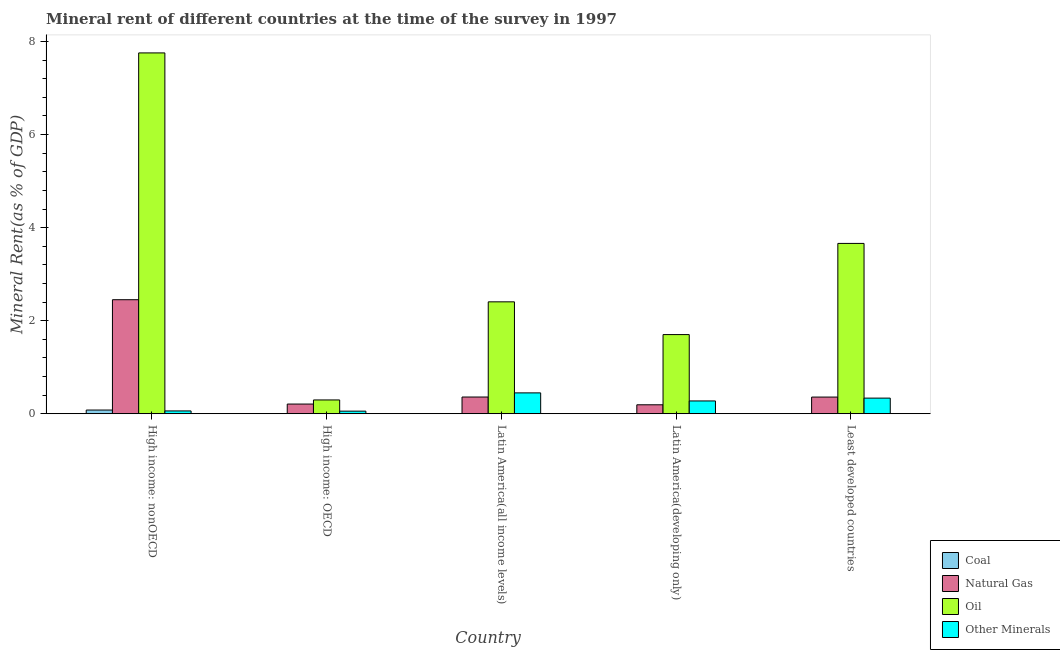How many bars are there on the 5th tick from the left?
Provide a short and direct response. 4. What is the label of the 1st group of bars from the left?
Provide a succinct answer. High income: nonOECD. In how many cases, is the number of bars for a given country not equal to the number of legend labels?
Your answer should be compact. 0. What is the oil rent in Latin America(all income levels)?
Provide a short and direct response. 2.4. Across all countries, what is the maximum oil rent?
Provide a short and direct response. 7.75. Across all countries, what is the minimum  rent of other minerals?
Give a very brief answer. 0.06. In which country was the coal rent maximum?
Give a very brief answer. High income: nonOECD. In which country was the natural gas rent minimum?
Offer a very short reply. Latin America(developing only). What is the total coal rent in the graph?
Give a very brief answer. 0.09. What is the difference between the oil rent in Latin America(all income levels) and that in Latin America(developing only)?
Give a very brief answer. 0.7. What is the difference between the natural gas rent in Latin America(all income levels) and the  rent of other minerals in Latin America(developing only)?
Offer a terse response. 0.08. What is the average  rent of other minerals per country?
Offer a very short reply. 0.23. What is the difference between the natural gas rent and  rent of other minerals in High income: nonOECD?
Your response must be concise. 2.39. What is the ratio of the  rent of other minerals in High income: nonOECD to that in Least developed countries?
Ensure brevity in your answer.  0.18. What is the difference between the highest and the second highest  rent of other minerals?
Make the answer very short. 0.11. What is the difference between the highest and the lowest oil rent?
Ensure brevity in your answer.  7.46. In how many countries, is the oil rent greater than the average oil rent taken over all countries?
Keep it short and to the point. 2. What does the 2nd bar from the left in Latin America(all income levels) represents?
Give a very brief answer. Natural Gas. What does the 1st bar from the right in Latin America(all income levels) represents?
Give a very brief answer. Other Minerals. Is it the case that in every country, the sum of the coal rent and natural gas rent is greater than the oil rent?
Keep it short and to the point. No. Are all the bars in the graph horizontal?
Offer a terse response. No. How many countries are there in the graph?
Your answer should be compact. 5. Does the graph contain grids?
Offer a terse response. No. How many legend labels are there?
Offer a very short reply. 4. How are the legend labels stacked?
Offer a very short reply. Vertical. What is the title of the graph?
Provide a succinct answer. Mineral rent of different countries at the time of the survey in 1997. What is the label or title of the X-axis?
Provide a succinct answer. Country. What is the label or title of the Y-axis?
Offer a very short reply. Mineral Rent(as % of GDP). What is the Mineral Rent(as % of GDP) of Coal in High income: nonOECD?
Ensure brevity in your answer.  0.08. What is the Mineral Rent(as % of GDP) of Natural Gas in High income: nonOECD?
Provide a succinct answer. 2.45. What is the Mineral Rent(as % of GDP) in Oil in High income: nonOECD?
Your response must be concise. 7.75. What is the Mineral Rent(as % of GDP) of Other Minerals in High income: nonOECD?
Give a very brief answer. 0.06. What is the Mineral Rent(as % of GDP) of Coal in High income: OECD?
Your answer should be very brief. 0. What is the Mineral Rent(as % of GDP) in Natural Gas in High income: OECD?
Offer a terse response. 0.21. What is the Mineral Rent(as % of GDP) in Oil in High income: OECD?
Your response must be concise. 0.3. What is the Mineral Rent(as % of GDP) in Other Minerals in High income: OECD?
Ensure brevity in your answer.  0.06. What is the Mineral Rent(as % of GDP) in Coal in Latin America(all income levels)?
Make the answer very short. 0. What is the Mineral Rent(as % of GDP) in Natural Gas in Latin America(all income levels)?
Make the answer very short. 0.36. What is the Mineral Rent(as % of GDP) in Oil in Latin America(all income levels)?
Provide a short and direct response. 2.4. What is the Mineral Rent(as % of GDP) in Other Minerals in Latin America(all income levels)?
Offer a very short reply. 0.45. What is the Mineral Rent(as % of GDP) in Coal in Latin America(developing only)?
Make the answer very short. 0. What is the Mineral Rent(as % of GDP) of Natural Gas in Latin America(developing only)?
Make the answer very short. 0.19. What is the Mineral Rent(as % of GDP) of Oil in Latin America(developing only)?
Make the answer very short. 1.7. What is the Mineral Rent(as % of GDP) of Other Minerals in Latin America(developing only)?
Ensure brevity in your answer.  0.27. What is the Mineral Rent(as % of GDP) in Coal in Least developed countries?
Keep it short and to the point. 0. What is the Mineral Rent(as % of GDP) of Natural Gas in Least developed countries?
Offer a very short reply. 0.36. What is the Mineral Rent(as % of GDP) in Oil in Least developed countries?
Your answer should be compact. 3.66. What is the Mineral Rent(as % of GDP) of Other Minerals in Least developed countries?
Keep it short and to the point. 0.34. Across all countries, what is the maximum Mineral Rent(as % of GDP) of Coal?
Offer a very short reply. 0.08. Across all countries, what is the maximum Mineral Rent(as % of GDP) in Natural Gas?
Provide a succinct answer. 2.45. Across all countries, what is the maximum Mineral Rent(as % of GDP) in Oil?
Provide a succinct answer. 7.75. Across all countries, what is the maximum Mineral Rent(as % of GDP) in Other Minerals?
Offer a terse response. 0.45. Across all countries, what is the minimum Mineral Rent(as % of GDP) in Coal?
Make the answer very short. 0. Across all countries, what is the minimum Mineral Rent(as % of GDP) in Natural Gas?
Offer a terse response. 0.19. Across all countries, what is the minimum Mineral Rent(as % of GDP) of Oil?
Offer a very short reply. 0.3. Across all countries, what is the minimum Mineral Rent(as % of GDP) of Other Minerals?
Your answer should be very brief. 0.06. What is the total Mineral Rent(as % of GDP) in Coal in the graph?
Offer a terse response. 0.09. What is the total Mineral Rent(as % of GDP) of Natural Gas in the graph?
Your answer should be compact. 3.57. What is the total Mineral Rent(as % of GDP) in Oil in the graph?
Your answer should be compact. 15.82. What is the total Mineral Rent(as % of GDP) of Other Minerals in the graph?
Provide a short and direct response. 1.17. What is the difference between the Mineral Rent(as % of GDP) of Coal in High income: nonOECD and that in High income: OECD?
Provide a short and direct response. 0.08. What is the difference between the Mineral Rent(as % of GDP) in Natural Gas in High income: nonOECD and that in High income: OECD?
Make the answer very short. 2.24. What is the difference between the Mineral Rent(as % of GDP) of Oil in High income: nonOECD and that in High income: OECD?
Keep it short and to the point. 7.46. What is the difference between the Mineral Rent(as % of GDP) in Other Minerals in High income: nonOECD and that in High income: OECD?
Ensure brevity in your answer.  0. What is the difference between the Mineral Rent(as % of GDP) of Coal in High income: nonOECD and that in Latin America(all income levels)?
Keep it short and to the point. 0.08. What is the difference between the Mineral Rent(as % of GDP) of Natural Gas in High income: nonOECD and that in Latin America(all income levels)?
Your answer should be compact. 2.09. What is the difference between the Mineral Rent(as % of GDP) of Oil in High income: nonOECD and that in Latin America(all income levels)?
Ensure brevity in your answer.  5.35. What is the difference between the Mineral Rent(as % of GDP) in Other Minerals in High income: nonOECD and that in Latin America(all income levels)?
Your answer should be compact. -0.39. What is the difference between the Mineral Rent(as % of GDP) of Coal in High income: nonOECD and that in Latin America(developing only)?
Give a very brief answer. 0.08. What is the difference between the Mineral Rent(as % of GDP) of Natural Gas in High income: nonOECD and that in Latin America(developing only)?
Offer a very short reply. 2.26. What is the difference between the Mineral Rent(as % of GDP) of Oil in High income: nonOECD and that in Latin America(developing only)?
Offer a very short reply. 6.05. What is the difference between the Mineral Rent(as % of GDP) in Other Minerals in High income: nonOECD and that in Latin America(developing only)?
Give a very brief answer. -0.21. What is the difference between the Mineral Rent(as % of GDP) of Coal in High income: nonOECD and that in Least developed countries?
Your response must be concise. 0.08. What is the difference between the Mineral Rent(as % of GDP) of Natural Gas in High income: nonOECD and that in Least developed countries?
Your answer should be compact. 2.09. What is the difference between the Mineral Rent(as % of GDP) in Oil in High income: nonOECD and that in Least developed countries?
Offer a terse response. 4.09. What is the difference between the Mineral Rent(as % of GDP) in Other Minerals in High income: nonOECD and that in Least developed countries?
Keep it short and to the point. -0.28. What is the difference between the Mineral Rent(as % of GDP) of Coal in High income: OECD and that in Latin America(all income levels)?
Make the answer very short. 0. What is the difference between the Mineral Rent(as % of GDP) of Natural Gas in High income: OECD and that in Latin America(all income levels)?
Make the answer very short. -0.15. What is the difference between the Mineral Rent(as % of GDP) of Oil in High income: OECD and that in Latin America(all income levels)?
Provide a succinct answer. -2.11. What is the difference between the Mineral Rent(as % of GDP) of Other Minerals in High income: OECD and that in Latin America(all income levels)?
Ensure brevity in your answer.  -0.39. What is the difference between the Mineral Rent(as % of GDP) in Coal in High income: OECD and that in Latin America(developing only)?
Your answer should be compact. -0. What is the difference between the Mineral Rent(as % of GDP) of Natural Gas in High income: OECD and that in Latin America(developing only)?
Offer a terse response. 0.02. What is the difference between the Mineral Rent(as % of GDP) in Oil in High income: OECD and that in Latin America(developing only)?
Give a very brief answer. -1.4. What is the difference between the Mineral Rent(as % of GDP) of Other Minerals in High income: OECD and that in Latin America(developing only)?
Give a very brief answer. -0.22. What is the difference between the Mineral Rent(as % of GDP) in Coal in High income: OECD and that in Least developed countries?
Offer a very short reply. 0. What is the difference between the Mineral Rent(as % of GDP) of Natural Gas in High income: OECD and that in Least developed countries?
Provide a short and direct response. -0.15. What is the difference between the Mineral Rent(as % of GDP) of Oil in High income: OECD and that in Least developed countries?
Your response must be concise. -3.36. What is the difference between the Mineral Rent(as % of GDP) of Other Minerals in High income: OECD and that in Least developed countries?
Give a very brief answer. -0.28. What is the difference between the Mineral Rent(as % of GDP) of Coal in Latin America(all income levels) and that in Latin America(developing only)?
Provide a succinct answer. -0. What is the difference between the Mineral Rent(as % of GDP) in Oil in Latin America(all income levels) and that in Latin America(developing only)?
Provide a succinct answer. 0.7. What is the difference between the Mineral Rent(as % of GDP) of Other Minerals in Latin America(all income levels) and that in Latin America(developing only)?
Your answer should be very brief. 0.17. What is the difference between the Mineral Rent(as % of GDP) in Coal in Latin America(all income levels) and that in Least developed countries?
Your answer should be compact. 0. What is the difference between the Mineral Rent(as % of GDP) of Natural Gas in Latin America(all income levels) and that in Least developed countries?
Make the answer very short. 0. What is the difference between the Mineral Rent(as % of GDP) in Oil in Latin America(all income levels) and that in Least developed countries?
Offer a terse response. -1.26. What is the difference between the Mineral Rent(as % of GDP) in Other Minerals in Latin America(all income levels) and that in Least developed countries?
Your answer should be very brief. 0.11. What is the difference between the Mineral Rent(as % of GDP) in Coal in Latin America(developing only) and that in Least developed countries?
Give a very brief answer. 0. What is the difference between the Mineral Rent(as % of GDP) of Natural Gas in Latin America(developing only) and that in Least developed countries?
Keep it short and to the point. -0.17. What is the difference between the Mineral Rent(as % of GDP) in Oil in Latin America(developing only) and that in Least developed countries?
Your answer should be very brief. -1.96. What is the difference between the Mineral Rent(as % of GDP) in Other Minerals in Latin America(developing only) and that in Least developed countries?
Keep it short and to the point. -0.06. What is the difference between the Mineral Rent(as % of GDP) of Coal in High income: nonOECD and the Mineral Rent(as % of GDP) of Natural Gas in High income: OECD?
Your answer should be very brief. -0.13. What is the difference between the Mineral Rent(as % of GDP) in Coal in High income: nonOECD and the Mineral Rent(as % of GDP) in Oil in High income: OECD?
Keep it short and to the point. -0.22. What is the difference between the Mineral Rent(as % of GDP) in Coal in High income: nonOECD and the Mineral Rent(as % of GDP) in Other Minerals in High income: OECD?
Provide a succinct answer. 0.02. What is the difference between the Mineral Rent(as % of GDP) in Natural Gas in High income: nonOECD and the Mineral Rent(as % of GDP) in Oil in High income: OECD?
Your answer should be compact. 2.15. What is the difference between the Mineral Rent(as % of GDP) of Natural Gas in High income: nonOECD and the Mineral Rent(as % of GDP) of Other Minerals in High income: OECD?
Ensure brevity in your answer.  2.4. What is the difference between the Mineral Rent(as % of GDP) in Oil in High income: nonOECD and the Mineral Rent(as % of GDP) in Other Minerals in High income: OECD?
Provide a succinct answer. 7.7. What is the difference between the Mineral Rent(as % of GDP) of Coal in High income: nonOECD and the Mineral Rent(as % of GDP) of Natural Gas in Latin America(all income levels)?
Keep it short and to the point. -0.28. What is the difference between the Mineral Rent(as % of GDP) of Coal in High income: nonOECD and the Mineral Rent(as % of GDP) of Oil in Latin America(all income levels)?
Ensure brevity in your answer.  -2.33. What is the difference between the Mineral Rent(as % of GDP) in Coal in High income: nonOECD and the Mineral Rent(as % of GDP) in Other Minerals in Latin America(all income levels)?
Make the answer very short. -0.37. What is the difference between the Mineral Rent(as % of GDP) in Natural Gas in High income: nonOECD and the Mineral Rent(as % of GDP) in Oil in Latin America(all income levels)?
Offer a very short reply. 0.05. What is the difference between the Mineral Rent(as % of GDP) in Natural Gas in High income: nonOECD and the Mineral Rent(as % of GDP) in Other Minerals in Latin America(all income levels)?
Provide a short and direct response. 2. What is the difference between the Mineral Rent(as % of GDP) of Oil in High income: nonOECD and the Mineral Rent(as % of GDP) of Other Minerals in Latin America(all income levels)?
Keep it short and to the point. 7.31. What is the difference between the Mineral Rent(as % of GDP) of Coal in High income: nonOECD and the Mineral Rent(as % of GDP) of Natural Gas in Latin America(developing only)?
Give a very brief answer. -0.11. What is the difference between the Mineral Rent(as % of GDP) in Coal in High income: nonOECD and the Mineral Rent(as % of GDP) in Oil in Latin America(developing only)?
Your answer should be very brief. -1.62. What is the difference between the Mineral Rent(as % of GDP) of Coal in High income: nonOECD and the Mineral Rent(as % of GDP) of Other Minerals in Latin America(developing only)?
Make the answer very short. -0.2. What is the difference between the Mineral Rent(as % of GDP) of Natural Gas in High income: nonOECD and the Mineral Rent(as % of GDP) of Oil in Latin America(developing only)?
Provide a succinct answer. 0.75. What is the difference between the Mineral Rent(as % of GDP) of Natural Gas in High income: nonOECD and the Mineral Rent(as % of GDP) of Other Minerals in Latin America(developing only)?
Give a very brief answer. 2.18. What is the difference between the Mineral Rent(as % of GDP) of Oil in High income: nonOECD and the Mineral Rent(as % of GDP) of Other Minerals in Latin America(developing only)?
Ensure brevity in your answer.  7.48. What is the difference between the Mineral Rent(as % of GDP) of Coal in High income: nonOECD and the Mineral Rent(as % of GDP) of Natural Gas in Least developed countries?
Provide a succinct answer. -0.28. What is the difference between the Mineral Rent(as % of GDP) of Coal in High income: nonOECD and the Mineral Rent(as % of GDP) of Oil in Least developed countries?
Give a very brief answer. -3.58. What is the difference between the Mineral Rent(as % of GDP) of Coal in High income: nonOECD and the Mineral Rent(as % of GDP) of Other Minerals in Least developed countries?
Provide a short and direct response. -0.26. What is the difference between the Mineral Rent(as % of GDP) in Natural Gas in High income: nonOECD and the Mineral Rent(as % of GDP) in Oil in Least developed countries?
Offer a terse response. -1.21. What is the difference between the Mineral Rent(as % of GDP) of Natural Gas in High income: nonOECD and the Mineral Rent(as % of GDP) of Other Minerals in Least developed countries?
Your answer should be compact. 2.11. What is the difference between the Mineral Rent(as % of GDP) of Oil in High income: nonOECD and the Mineral Rent(as % of GDP) of Other Minerals in Least developed countries?
Give a very brief answer. 7.42. What is the difference between the Mineral Rent(as % of GDP) in Coal in High income: OECD and the Mineral Rent(as % of GDP) in Natural Gas in Latin America(all income levels)?
Provide a succinct answer. -0.36. What is the difference between the Mineral Rent(as % of GDP) in Coal in High income: OECD and the Mineral Rent(as % of GDP) in Oil in Latin America(all income levels)?
Make the answer very short. -2.4. What is the difference between the Mineral Rent(as % of GDP) of Coal in High income: OECD and the Mineral Rent(as % of GDP) of Other Minerals in Latin America(all income levels)?
Your response must be concise. -0.45. What is the difference between the Mineral Rent(as % of GDP) of Natural Gas in High income: OECD and the Mineral Rent(as % of GDP) of Oil in Latin America(all income levels)?
Your answer should be very brief. -2.2. What is the difference between the Mineral Rent(as % of GDP) in Natural Gas in High income: OECD and the Mineral Rent(as % of GDP) in Other Minerals in Latin America(all income levels)?
Offer a very short reply. -0.24. What is the difference between the Mineral Rent(as % of GDP) of Oil in High income: OECD and the Mineral Rent(as % of GDP) of Other Minerals in Latin America(all income levels)?
Your answer should be compact. -0.15. What is the difference between the Mineral Rent(as % of GDP) in Coal in High income: OECD and the Mineral Rent(as % of GDP) in Natural Gas in Latin America(developing only)?
Keep it short and to the point. -0.19. What is the difference between the Mineral Rent(as % of GDP) of Coal in High income: OECD and the Mineral Rent(as % of GDP) of Oil in Latin America(developing only)?
Your response must be concise. -1.7. What is the difference between the Mineral Rent(as % of GDP) in Coal in High income: OECD and the Mineral Rent(as % of GDP) in Other Minerals in Latin America(developing only)?
Ensure brevity in your answer.  -0.27. What is the difference between the Mineral Rent(as % of GDP) in Natural Gas in High income: OECD and the Mineral Rent(as % of GDP) in Oil in Latin America(developing only)?
Give a very brief answer. -1.49. What is the difference between the Mineral Rent(as % of GDP) in Natural Gas in High income: OECD and the Mineral Rent(as % of GDP) in Other Minerals in Latin America(developing only)?
Your answer should be compact. -0.07. What is the difference between the Mineral Rent(as % of GDP) of Oil in High income: OECD and the Mineral Rent(as % of GDP) of Other Minerals in Latin America(developing only)?
Provide a succinct answer. 0.02. What is the difference between the Mineral Rent(as % of GDP) in Coal in High income: OECD and the Mineral Rent(as % of GDP) in Natural Gas in Least developed countries?
Provide a short and direct response. -0.36. What is the difference between the Mineral Rent(as % of GDP) in Coal in High income: OECD and the Mineral Rent(as % of GDP) in Oil in Least developed countries?
Make the answer very short. -3.66. What is the difference between the Mineral Rent(as % of GDP) in Coal in High income: OECD and the Mineral Rent(as % of GDP) in Other Minerals in Least developed countries?
Ensure brevity in your answer.  -0.33. What is the difference between the Mineral Rent(as % of GDP) in Natural Gas in High income: OECD and the Mineral Rent(as % of GDP) in Oil in Least developed countries?
Ensure brevity in your answer.  -3.45. What is the difference between the Mineral Rent(as % of GDP) of Natural Gas in High income: OECD and the Mineral Rent(as % of GDP) of Other Minerals in Least developed countries?
Ensure brevity in your answer.  -0.13. What is the difference between the Mineral Rent(as % of GDP) of Oil in High income: OECD and the Mineral Rent(as % of GDP) of Other Minerals in Least developed countries?
Offer a very short reply. -0.04. What is the difference between the Mineral Rent(as % of GDP) of Coal in Latin America(all income levels) and the Mineral Rent(as % of GDP) of Natural Gas in Latin America(developing only)?
Offer a terse response. -0.19. What is the difference between the Mineral Rent(as % of GDP) in Coal in Latin America(all income levels) and the Mineral Rent(as % of GDP) in Oil in Latin America(developing only)?
Offer a very short reply. -1.7. What is the difference between the Mineral Rent(as % of GDP) of Coal in Latin America(all income levels) and the Mineral Rent(as % of GDP) of Other Minerals in Latin America(developing only)?
Offer a terse response. -0.27. What is the difference between the Mineral Rent(as % of GDP) of Natural Gas in Latin America(all income levels) and the Mineral Rent(as % of GDP) of Oil in Latin America(developing only)?
Your answer should be compact. -1.34. What is the difference between the Mineral Rent(as % of GDP) of Natural Gas in Latin America(all income levels) and the Mineral Rent(as % of GDP) of Other Minerals in Latin America(developing only)?
Your answer should be compact. 0.08. What is the difference between the Mineral Rent(as % of GDP) in Oil in Latin America(all income levels) and the Mineral Rent(as % of GDP) in Other Minerals in Latin America(developing only)?
Your answer should be very brief. 2.13. What is the difference between the Mineral Rent(as % of GDP) in Coal in Latin America(all income levels) and the Mineral Rent(as % of GDP) in Natural Gas in Least developed countries?
Your response must be concise. -0.36. What is the difference between the Mineral Rent(as % of GDP) in Coal in Latin America(all income levels) and the Mineral Rent(as % of GDP) in Oil in Least developed countries?
Offer a terse response. -3.66. What is the difference between the Mineral Rent(as % of GDP) in Coal in Latin America(all income levels) and the Mineral Rent(as % of GDP) in Other Minerals in Least developed countries?
Provide a succinct answer. -0.33. What is the difference between the Mineral Rent(as % of GDP) of Natural Gas in Latin America(all income levels) and the Mineral Rent(as % of GDP) of Oil in Least developed countries?
Make the answer very short. -3.3. What is the difference between the Mineral Rent(as % of GDP) of Natural Gas in Latin America(all income levels) and the Mineral Rent(as % of GDP) of Other Minerals in Least developed countries?
Your response must be concise. 0.02. What is the difference between the Mineral Rent(as % of GDP) of Oil in Latin America(all income levels) and the Mineral Rent(as % of GDP) of Other Minerals in Least developed countries?
Your answer should be compact. 2.07. What is the difference between the Mineral Rent(as % of GDP) of Coal in Latin America(developing only) and the Mineral Rent(as % of GDP) of Natural Gas in Least developed countries?
Keep it short and to the point. -0.36. What is the difference between the Mineral Rent(as % of GDP) in Coal in Latin America(developing only) and the Mineral Rent(as % of GDP) in Oil in Least developed countries?
Offer a very short reply. -3.66. What is the difference between the Mineral Rent(as % of GDP) of Coal in Latin America(developing only) and the Mineral Rent(as % of GDP) of Other Minerals in Least developed countries?
Give a very brief answer. -0.33. What is the difference between the Mineral Rent(as % of GDP) of Natural Gas in Latin America(developing only) and the Mineral Rent(as % of GDP) of Oil in Least developed countries?
Your answer should be compact. -3.47. What is the difference between the Mineral Rent(as % of GDP) in Natural Gas in Latin America(developing only) and the Mineral Rent(as % of GDP) in Other Minerals in Least developed countries?
Keep it short and to the point. -0.14. What is the difference between the Mineral Rent(as % of GDP) in Oil in Latin America(developing only) and the Mineral Rent(as % of GDP) in Other Minerals in Least developed countries?
Keep it short and to the point. 1.37. What is the average Mineral Rent(as % of GDP) in Coal per country?
Offer a terse response. 0.02. What is the average Mineral Rent(as % of GDP) in Natural Gas per country?
Provide a succinct answer. 0.71. What is the average Mineral Rent(as % of GDP) in Oil per country?
Offer a terse response. 3.16. What is the average Mineral Rent(as % of GDP) of Other Minerals per country?
Make the answer very short. 0.23. What is the difference between the Mineral Rent(as % of GDP) in Coal and Mineral Rent(as % of GDP) in Natural Gas in High income: nonOECD?
Ensure brevity in your answer.  -2.37. What is the difference between the Mineral Rent(as % of GDP) in Coal and Mineral Rent(as % of GDP) in Oil in High income: nonOECD?
Provide a succinct answer. -7.67. What is the difference between the Mineral Rent(as % of GDP) in Coal and Mineral Rent(as % of GDP) in Other Minerals in High income: nonOECD?
Give a very brief answer. 0.02. What is the difference between the Mineral Rent(as % of GDP) of Natural Gas and Mineral Rent(as % of GDP) of Oil in High income: nonOECD?
Make the answer very short. -5.3. What is the difference between the Mineral Rent(as % of GDP) in Natural Gas and Mineral Rent(as % of GDP) in Other Minerals in High income: nonOECD?
Offer a terse response. 2.39. What is the difference between the Mineral Rent(as % of GDP) of Oil and Mineral Rent(as % of GDP) of Other Minerals in High income: nonOECD?
Your response must be concise. 7.69. What is the difference between the Mineral Rent(as % of GDP) of Coal and Mineral Rent(as % of GDP) of Natural Gas in High income: OECD?
Provide a short and direct response. -0.21. What is the difference between the Mineral Rent(as % of GDP) of Coal and Mineral Rent(as % of GDP) of Oil in High income: OECD?
Offer a very short reply. -0.29. What is the difference between the Mineral Rent(as % of GDP) of Coal and Mineral Rent(as % of GDP) of Other Minerals in High income: OECD?
Keep it short and to the point. -0.05. What is the difference between the Mineral Rent(as % of GDP) in Natural Gas and Mineral Rent(as % of GDP) in Oil in High income: OECD?
Your answer should be very brief. -0.09. What is the difference between the Mineral Rent(as % of GDP) in Natural Gas and Mineral Rent(as % of GDP) in Other Minerals in High income: OECD?
Make the answer very short. 0.15. What is the difference between the Mineral Rent(as % of GDP) in Oil and Mineral Rent(as % of GDP) in Other Minerals in High income: OECD?
Give a very brief answer. 0.24. What is the difference between the Mineral Rent(as % of GDP) of Coal and Mineral Rent(as % of GDP) of Natural Gas in Latin America(all income levels)?
Make the answer very short. -0.36. What is the difference between the Mineral Rent(as % of GDP) in Coal and Mineral Rent(as % of GDP) in Oil in Latin America(all income levels)?
Keep it short and to the point. -2.4. What is the difference between the Mineral Rent(as % of GDP) in Coal and Mineral Rent(as % of GDP) in Other Minerals in Latin America(all income levels)?
Provide a succinct answer. -0.45. What is the difference between the Mineral Rent(as % of GDP) of Natural Gas and Mineral Rent(as % of GDP) of Oil in Latin America(all income levels)?
Provide a short and direct response. -2.05. What is the difference between the Mineral Rent(as % of GDP) of Natural Gas and Mineral Rent(as % of GDP) of Other Minerals in Latin America(all income levels)?
Offer a very short reply. -0.09. What is the difference between the Mineral Rent(as % of GDP) in Oil and Mineral Rent(as % of GDP) in Other Minerals in Latin America(all income levels)?
Keep it short and to the point. 1.96. What is the difference between the Mineral Rent(as % of GDP) in Coal and Mineral Rent(as % of GDP) in Natural Gas in Latin America(developing only)?
Your response must be concise. -0.19. What is the difference between the Mineral Rent(as % of GDP) of Coal and Mineral Rent(as % of GDP) of Oil in Latin America(developing only)?
Offer a very short reply. -1.7. What is the difference between the Mineral Rent(as % of GDP) of Coal and Mineral Rent(as % of GDP) of Other Minerals in Latin America(developing only)?
Provide a succinct answer. -0.27. What is the difference between the Mineral Rent(as % of GDP) of Natural Gas and Mineral Rent(as % of GDP) of Oil in Latin America(developing only)?
Keep it short and to the point. -1.51. What is the difference between the Mineral Rent(as % of GDP) of Natural Gas and Mineral Rent(as % of GDP) of Other Minerals in Latin America(developing only)?
Provide a succinct answer. -0.08. What is the difference between the Mineral Rent(as % of GDP) of Oil and Mineral Rent(as % of GDP) of Other Minerals in Latin America(developing only)?
Give a very brief answer. 1.43. What is the difference between the Mineral Rent(as % of GDP) in Coal and Mineral Rent(as % of GDP) in Natural Gas in Least developed countries?
Your answer should be very brief. -0.36. What is the difference between the Mineral Rent(as % of GDP) in Coal and Mineral Rent(as % of GDP) in Oil in Least developed countries?
Ensure brevity in your answer.  -3.66. What is the difference between the Mineral Rent(as % of GDP) of Coal and Mineral Rent(as % of GDP) of Other Minerals in Least developed countries?
Offer a very short reply. -0.34. What is the difference between the Mineral Rent(as % of GDP) in Natural Gas and Mineral Rent(as % of GDP) in Oil in Least developed countries?
Your answer should be very brief. -3.3. What is the difference between the Mineral Rent(as % of GDP) in Natural Gas and Mineral Rent(as % of GDP) in Other Minerals in Least developed countries?
Offer a terse response. 0.02. What is the difference between the Mineral Rent(as % of GDP) of Oil and Mineral Rent(as % of GDP) of Other Minerals in Least developed countries?
Offer a very short reply. 3.32. What is the ratio of the Mineral Rent(as % of GDP) of Coal in High income: nonOECD to that in High income: OECD?
Offer a very short reply. 40.61. What is the ratio of the Mineral Rent(as % of GDP) of Natural Gas in High income: nonOECD to that in High income: OECD?
Offer a very short reply. 11.77. What is the ratio of the Mineral Rent(as % of GDP) of Oil in High income: nonOECD to that in High income: OECD?
Make the answer very short. 26.16. What is the ratio of the Mineral Rent(as % of GDP) of Other Minerals in High income: nonOECD to that in High income: OECD?
Give a very brief answer. 1.08. What is the ratio of the Mineral Rent(as % of GDP) of Coal in High income: nonOECD to that in Latin America(all income levels)?
Offer a terse response. 46.64. What is the ratio of the Mineral Rent(as % of GDP) of Natural Gas in High income: nonOECD to that in Latin America(all income levels)?
Give a very brief answer. 6.82. What is the ratio of the Mineral Rent(as % of GDP) of Oil in High income: nonOECD to that in Latin America(all income levels)?
Offer a very short reply. 3.22. What is the ratio of the Mineral Rent(as % of GDP) in Other Minerals in High income: nonOECD to that in Latin America(all income levels)?
Offer a very short reply. 0.13. What is the ratio of the Mineral Rent(as % of GDP) in Coal in High income: nonOECD to that in Latin America(developing only)?
Make the answer very short. 35.23. What is the ratio of the Mineral Rent(as % of GDP) in Natural Gas in High income: nonOECD to that in Latin America(developing only)?
Provide a succinct answer. 12.73. What is the ratio of the Mineral Rent(as % of GDP) of Oil in High income: nonOECD to that in Latin America(developing only)?
Give a very brief answer. 4.56. What is the ratio of the Mineral Rent(as % of GDP) of Other Minerals in High income: nonOECD to that in Latin America(developing only)?
Offer a terse response. 0.22. What is the ratio of the Mineral Rent(as % of GDP) of Coal in High income: nonOECD to that in Least developed countries?
Ensure brevity in your answer.  291.24. What is the ratio of the Mineral Rent(as % of GDP) of Natural Gas in High income: nonOECD to that in Least developed countries?
Ensure brevity in your answer.  6.84. What is the ratio of the Mineral Rent(as % of GDP) in Oil in High income: nonOECD to that in Least developed countries?
Give a very brief answer. 2.12. What is the ratio of the Mineral Rent(as % of GDP) of Other Minerals in High income: nonOECD to that in Least developed countries?
Ensure brevity in your answer.  0.18. What is the ratio of the Mineral Rent(as % of GDP) in Coal in High income: OECD to that in Latin America(all income levels)?
Your answer should be very brief. 1.15. What is the ratio of the Mineral Rent(as % of GDP) of Natural Gas in High income: OECD to that in Latin America(all income levels)?
Keep it short and to the point. 0.58. What is the ratio of the Mineral Rent(as % of GDP) in Oil in High income: OECD to that in Latin America(all income levels)?
Ensure brevity in your answer.  0.12. What is the ratio of the Mineral Rent(as % of GDP) of Other Minerals in High income: OECD to that in Latin America(all income levels)?
Your answer should be compact. 0.12. What is the ratio of the Mineral Rent(as % of GDP) of Coal in High income: OECD to that in Latin America(developing only)?
Your answer should be compact. 0.87. What is the ratio of the Mineral Rent(as % of GDP) in Natural Gas in High income: OECD to that in Latin America(developing only)?
Give a very brief answer. 1.08. What is the ratio of the Mineral Rent(as % of GDP) in Oil in High income: OECD to that in Latin America(developing only)?
Keep it short and to the point. 0.17. What is the ratio of the Mineral Rent(as % of GDP) of Other Minerals in High income: OECD to that in Latin America(developing only)?
Make the answer very short. 0.2. What is the ratio of the Mineral Rent(as % of GDP) in Coal in High income: OECD to that in Least developed countries?
Ensure brevity in your answer.  7.17. What is the ratio of the Mineral Rent(as % of GDP) in Natural Gas in High income: OECD to that in Least developed countries?
Ensure brevity in your answer.  0.58. What is the ratio of the Mineral Rent(as % of GDP) of Oil in High income: OECD to that in Least developed countries?
Make the answer very short. 0.08. What is the ratio of the Mineral Rent(as % of GDP) in Other Minerals in High income: OECD to that in Least developed countries?
Make the answer very short. 0.17. What is the ratio of the Mineral Rent(as % of GDP) of Coal in Latin America(all income levels) to that in Latin America(developing only)?
Give a very brief answer. 0.76. What is the ratio of the Mineral Rent(as % of GDP) of Natural Gas in Latin America(all income levels) to that in Latin America(developing only)?
Make the answer very short. 1.87. What is the ratio of the Mineral Rent(as % of GDP) of Oil in Latin America(all income levels) to that in Latin America(developing only)?
Give a very brief answer. 1.41. What is the ratio of the Mineral Rent(as % of GDP) of Other Minerals in Latin America(all income levels) to that in Latin America(developing only)?
Your answer should be very brief. 1.63. What is the ratio of the Mineral Rent(as % of GDP) of Coal in Latin America(all income levels) to that in Least developed countries?
Give a very brief answer. 6.24. What is the ratio of the Mineral Rent(as % of GDP) in Natural Gas in Latin America(all income levels) to that in Least developed countries?
Offer a very short reply. 1. What is the ratio of the Mineral Rent(as % of GDP) of Oil in Latin America(all income levels) to that in Least developed countries?
Provide a short and direct response. 0.66. What is the ratio of the Mineral Rent(as % of GDP) of Other Minerals in Latin America(all income levels) to that in Least developed countries?
Keep it short and to the point. 1.34. What is the ratio of the Mineral Rent(as % of GDP) of Coal in Latin America(developing only) to that in Least developed countries?
Provide a succinct answer. 8.27. What is the ratio of the Mineral Rent(as % of GDP) of Natural Gas in Latin America(developing only) to that in Least developed countries?
Offer a very short reply. 0.54. What is the ratio of the Mineral Rent(as % of GDP) of Oil in Latin America(developing only) to that in Least developed countries?
Make the answer very short. 0.46. What is the ratio of the Mineral Rent(as % of GDP) in Other Minerals in Latin America(developing only) to that in Least developed countries?
Your answer should be compact. 0.82. What is the difference between the highest and the second highest Mineral Rent(as % of GDP) of Coal?
Your answer should be compact. 0.08. What is the difference between the highest and the second highest Mineral Rent(as % of GDP) in Natural Gas?
Your answer should be very brief. 2.09. What is the difference between the highest and the second highest Mineral Rent(as % of GDP) of Oil?
Offer a terse response. 4.09. What is the difference between the highest and the second highest Mineral Rent(as % of GDP) of Other Minerals?
Your answer should be very brief. 0.11. What is the difference between the highest and the lowest Mineral Rent(as % of GDP) in Coal?
Keep it short and to the point. 0.08. What is the difference between the highest and the lowest Mineral Rent(as % of GDP) in Natural Gas?
Your answer should be compact. 2.26. What is the difference between the highest and the lowest Mineral Rent(as % of GDP) in Oil?
Provide a succinct answer. 7.46. What is the difference between the highest and the lowest Mineral Rent(as % of GDP) of Other Minerals?
Make the answer very short. 0.39. 